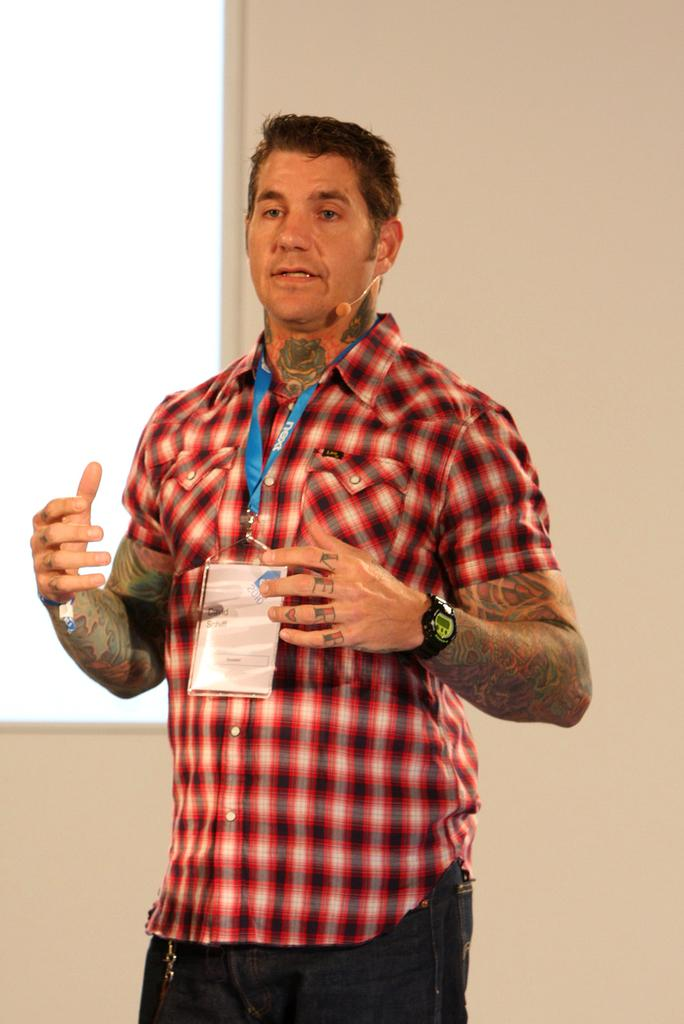What is the main subject of the image? There is a person standing in the center of the image. What can be seen on the person's clothing? The person is wearing an ID card. What object is present in the image that is typically used for amplifying sound? There is a microphone (mic) in the image. What can be seen in the background of the image? There is a wall in the background of the image. What type of bubble can be seen floating near the person in the image? There is no bubble present in the image; it only features a person, an ID card, a microphone, and a wall in the background. 